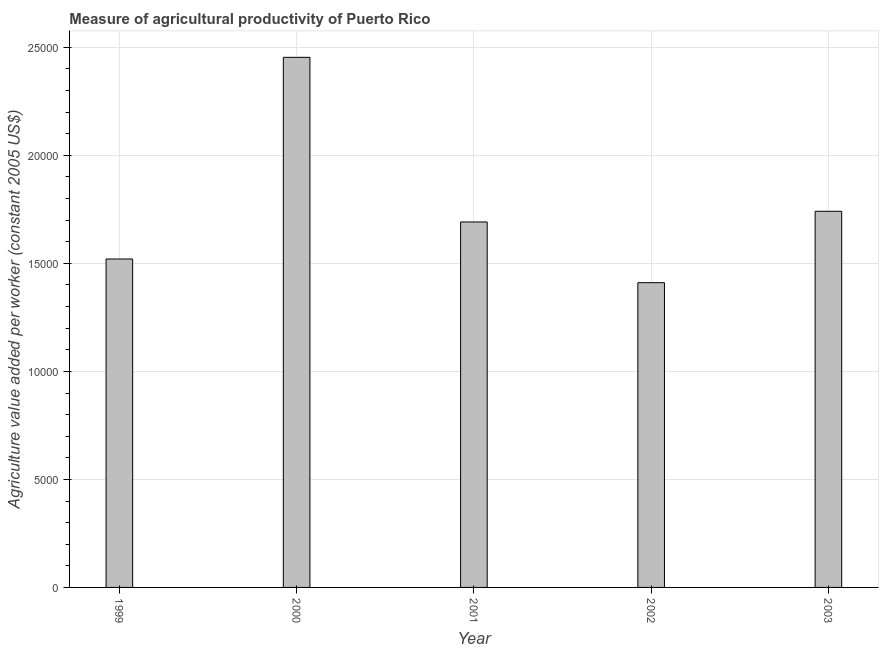Does the graph contain grids?
Your answer should be compact. Yes. What is the title of the graph?
Ensure brevity in your answer.  Measure of agricultural productivity of Puerto Rico. What is the label or title of the Y-axis?
Provide a short and direct response. Agriculture value added per worker (constant 2005 US$). What is the agriculture value added per worker in 2003?
Your response must be concise. 1.74e+04. Across all years, what is the maximum agriculture value added per worker?
Your answer should be compact. 2.45e+04. Across all years, what is the minimum agriculture value added per worker?
Provide a succinct answer. 1.41e+04. In which year was the agriculture value added per worker maximum?
Your response must be concise. 2000. In which year was the agriculture value added per worker minimum?
Keep it short and to the point. 2002. What is the sum of the agriculture value added per worker?
Ensure brevity in your answer.  8.82e+04. What is the difference between the agriculture value added per worker in 2001 and 2003?
Ensure brevity in your answer.  -493.81. What is the average agriculture value added per worker per year?
Ensure brevity in your answer.  1.76e+04. What is the median agriculture value added per worker?
Ensure brevity in your answer.  1.69e+04. In how many years, is the agriculture value added per worker greater than 4000 US$?
Your answer should be compact. 5. What is the ratio of the agriculture value added per worker in 2001 to that in 2003?
Your answer should be compact. 0.97. Is the agriculture value added per worker in 2001 less than that in 2003?
Provide a succinct answer. Yes. Is the difference between the agriculture value added per worker in 1999 and 2001 greater than the difference between any two years?
Ensure brevity in your answer.  No. What is the difference between the highest and the second highest agriculture value added per worker?
Provide a short and direct response. 7126.76. What is the difference between the highest and the lowest agriculture value added per worker?
Provide a succinct answer. 1.04e+04. In how many years, is the agriculture value added per worker greater than the average agriculture value added per worker taken over all years?
Your answer should be compact. 1. How many years are there in the graph?
Your answer should be compact. 5. What is the difference between two consecutive major ticks on the Y-axis?
Give a very brief answer. 5000. Are the values on the major ticks of Y-axis written in scientific E-notation?
Make the answer very short. No. What is the Agriculture value added per worker (constant 2005 US$) of 1999?
Provide a succinct answer. 1.52e+04. What is the Agriculture value added per worker (constant 2005 US$) of 2000?
Provide a succinct answer. 2.45e+04. What is the Agriculture value added per worker (constant 2005 US$) in 2001?
Provide a short and direct response. 1.69e+04. What is the Agriculture value added per worker (constant 2005 US$) of 2002?
Offer a very short reply. 1.41e+04. What is the Agriculture value added per worker (constant 2005 US$) of 2003?
Your response must be concise. 1.74e+04. What is the difference between the Agriculture value added per worker (constant 2005 US$) in 1999 and 2000?
Offer a very short reply. -9335.2. What is the difference between the Agriculture value added per worker (constant 2005 US$) in 1999 and 2001?
Your answer should be very brief. -1714.63. What is the difference between the Agriculture value added per worker (constant 2005 US$) in 1999 and 2002?
Offer a very short reply. 1096.52. What is the difference between the Agriculture value added per worker (constant 2005 US$) in 1999 and 2003?
Give a very brief answer. -2208.44. What is the difference between the Agriculture value added per worker (constant 2005 US$) in 2000 and 2001?
Your answer should be very brief. 7620.57. What is the difference between the Agriculture value added per worker (constant 2005 US$) in 2000 and 2002?
Ensure brevity in your answer.  1.04e+04. What is the difference between the Agriculture value added per worker (constant 2005 US$) in 2000 and 2003?
Your answer should be very brief. 7126.76. What is the difference between the Agriculture value added per worker (constant 2005 US$) in 2001 and 2002?
Provide a short and direct response. 2811.15. What is the difference between the Agriculture value added per worker (constant 2005 US$) in 2001 and 2003?
Provide a succinct answer. -493.81. What is the difference between the Agriculture value added per worker (constant 2005 US$) in 2002 and 2003?
Give a very brief answer. -3304.96. What is the ratio of the Agriculture value added per worker (constant 2005 US$) in 1999 to that in 2000?
Offer a terse response. 0.62. What is the ratio of the Agriculture value added per worker (constant 2005 US$) in 1999 to that in 2001?
Your answer should be very brief. 0.9. What is the ratio of the Agriculture value added per worker (constant 2005 US$) in 1999 to that in 2002?
Provide a succinct answer. 1.08. What is the ratio of the Agriculture value added per worker (constant 2005 US$) in 1999 to that in 2003?
Provide a short and direct response. 0.87. What is the ratio of the Agriculture value added per worker (constant 2005 US$) in 2000 to that in 2001?
Your answer should be very brief. 1.45. What is the ratio of the Agriculture value added per worker (constant 2005 US$) in 2000 to that in 2002?
Make the answer very short. 1.74. What is the ratio of the Agriculture value added per worker (constant 2005 US$) in 2000 to that in 2003?
Provide a short and direct response. 1.41. What is the ratio of the Agriculture value added per worker (constant 2005 US$) in 2001 to that in 2002?
Your answer should be compact. 1.2. What is the ratio of the Agriculture value added per worker (constant 2005 US$) in 2002 to that in 2003?
Provide a succinct answer. 0.81. 